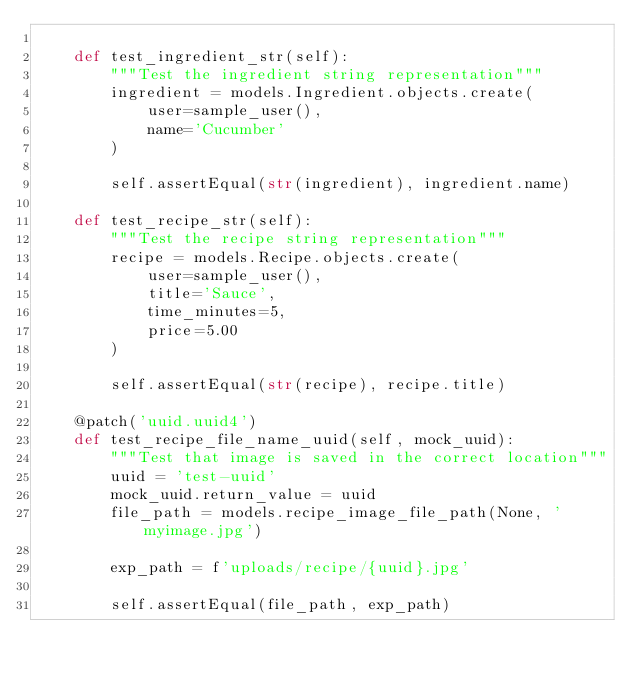<code> <loc_0><loc_0><loc_500><loc_500><_Python_>
    def test_ingredient_str(self):
        """Test the ingredient string representation"""
        ingredient = models.Ingredient.objects.create(
            user=sample_user(),
            name='Cucumber'
        )

        self.assertEqual(str(ingredient), ingredient.name)

    def test_recipe_str(self):
        """Test the recipe string representation"""
        recipe = models.Recipe.objects.create(
            user=sample_user(),
            title='Sauce',
            time_minutes=5,
            price=5.00
        )

        self.assertEqual(str(recipe), recipe.title)

    @patch('uuid.uuid4')
    def test_recipe_file_name_uuid(self, mock_uuid):
        """Test that image is saved in the correct location"""
        uuid = 'test-uuid'
        mock_uuid.return_value = uuid
        file_path = models.recipe_image_file_path(None, 'myimage.jpg')

        exp_path = f'uploads/recipe/{uuid}.jpg'

        self.assertEqual(file_path, exp_path)
</code> 